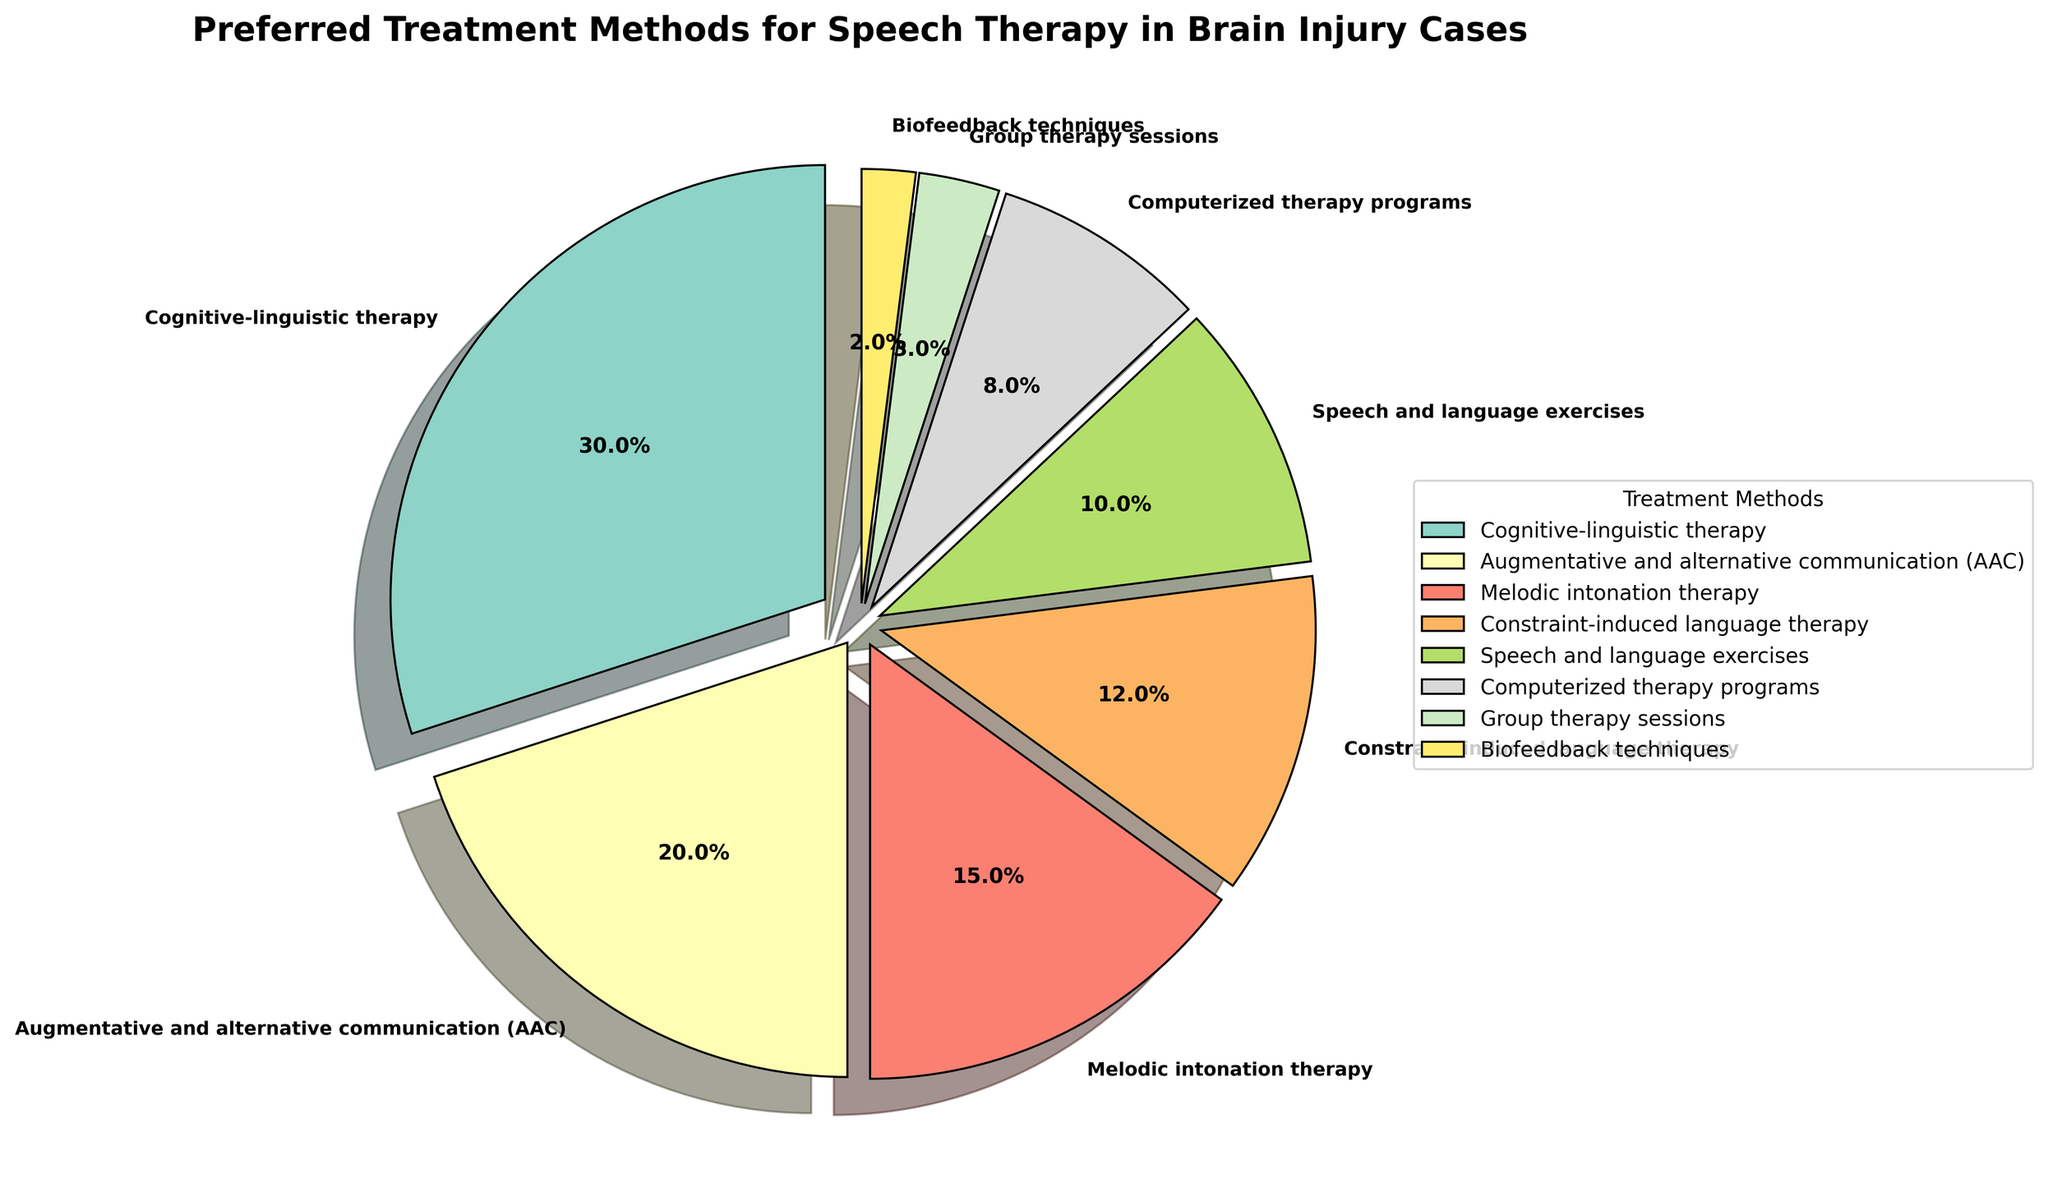What is the most preferred treatment method depicted in the pie chart? The most preferred treatment method is the one with the highest percentage. In the pie chart, Cognitive-linguistic therapy is represented with the largest wedge, indicating it makes up 30% of the preferences.
Answer: Cognitive-linguistic therapy Which treatment method has the lowest preference among the options? The least preferred treatment method will have the smallest percentage. In the pie chart, Biofeedback techniques have the smallest wedge, indicating it makes up only 2% of the preferences.
Answer: Biofeedback techniques What is the combined percentage for Augmentative and alternative communication (AAC) and Melodic intonation therapy? To find the combined percentage, sum the percentages of AAC and Melodic intonation therapy. AAC is 20% and Melodic intonation therapy is 15%, so their combined percentage is 20% + 15% = 35%.
Answer: 35% How does the preference for Constraint-induced language therapy compare to Speech and language exercises? To compare, look at their percentages in the pie chart. Constraint-induced language therapy has a preference of 12%, while Speech and language exercises have 10%. Constraint-induced language therapy is preferred by 2% more.
Answer: Constraint-induced language therapy is preferred by 2% more What percentage of treatments involve computerized components (including only Computerized therapy programs)? The percentage for Computerized therapy programs is 8% according to the pie chart.
Answer: 8% What is the total percentage of treatment methods that are preferred by less than 10% of the respondents? Sum the percentages of all methods with less than 10% preference. These are Speech and language exercises (10%), Computerized therapy programs (8%), Group therapy sessions (3%), and Biofeedback techniques (2%). The total is 10% + 8% + 3% + 2% = 23%.
Answer: 23% If we combine the less traditional therapies, including Melodic intonation therapy, Constraint-induced language therapy, Group therapy sessions, and Biofeedback techniques, what is their total percentage? Add the percentages of these therapies: Melodic intonation therapy (15%), Constraint-induced language therapy (12%), Group therapy sessions (3%), and Biofeedback techniques (2%). The total is 15% + 12% + 3% + 2% = 32%.
Answer: 32% How does the preference for Melodic intonation therapy compare to Group therapy sessions in terms of ratio? Divide the percentage of Melodic intonation therapy by the percentage of Group therapy sessions. Melodic intonation therapy is 15%, and Group therapy sessions are 3%, so the ratio is 15/3 = 5.
Answer: 5:1 What percentage of treatments involve either Cognitive-linguistic therapy or Augmentative and alternative communication (AAC)? Sum the percentages of Cognitive-linguistic therapy (30%) and AAC (20%). The total is 30% + 20% = 50%.
Answer: 50% Which treatment methods, if any, share the same visual characteristics in terms of color on the pie chart? No two treatment methods share the same color because the colors are generated using a color map to ensure each slice is unique.
Answer: No methods share the same color 